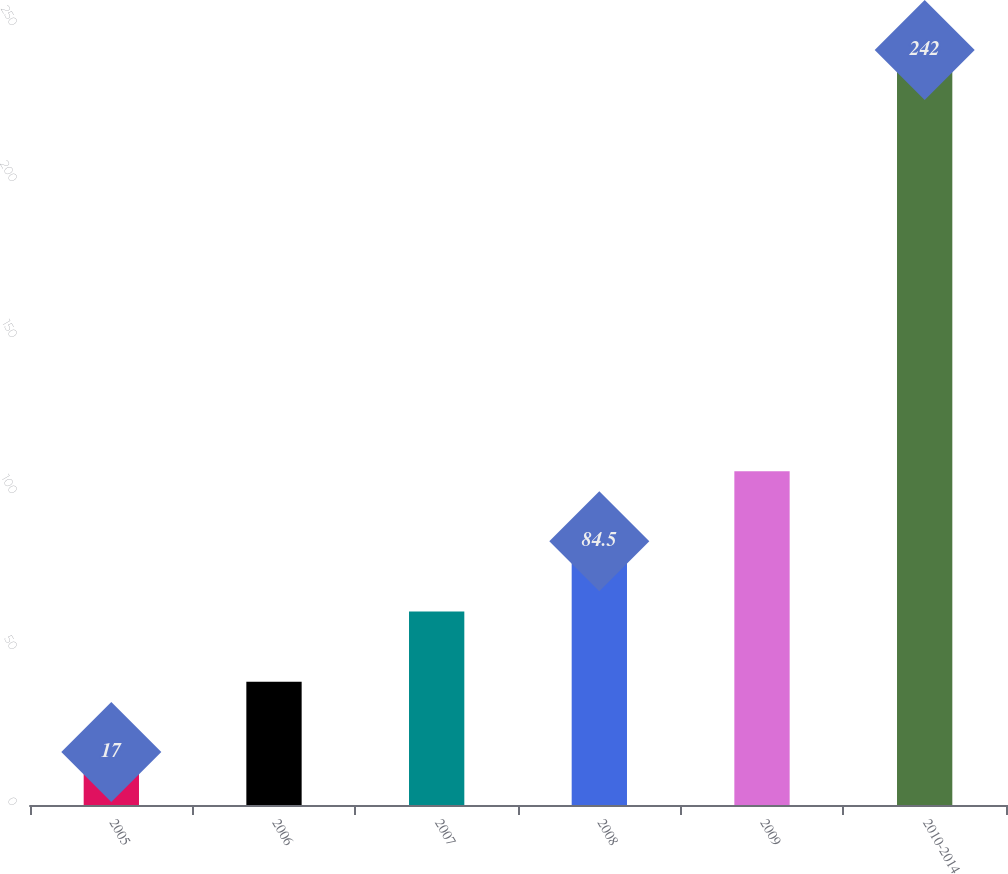Convert chart to OTSL. <chart><loc_0><loc_0><loc_500><loc_500><bar_chart><fcel>2005<fcel>2006<fcel>2007<fcel>2008<fcel>2009<fcel>2010-2014<nl><fcel>17<fcel>39.5<fcel>62<fcel>84.5<fcel>107<fcel>242<nl></chart> 